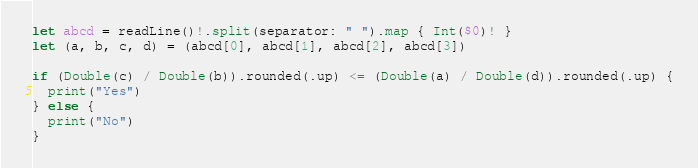Convert code to text. <code><loc_0><loc_0><loc_500><loc_500><_Swift_>let abcd = readLine()!.split(separator: " ").map { Int($0)! }
let (a, b, c, d) = (abcd[0], abcd[1], abcd[2], abcd[3])

if (Double(c) / Double(b)).rounded(.up) <= (Double(a) / Double(d)).rounded(.up) {
  print("Yes")
} else {
  print("No")
}
</code> 